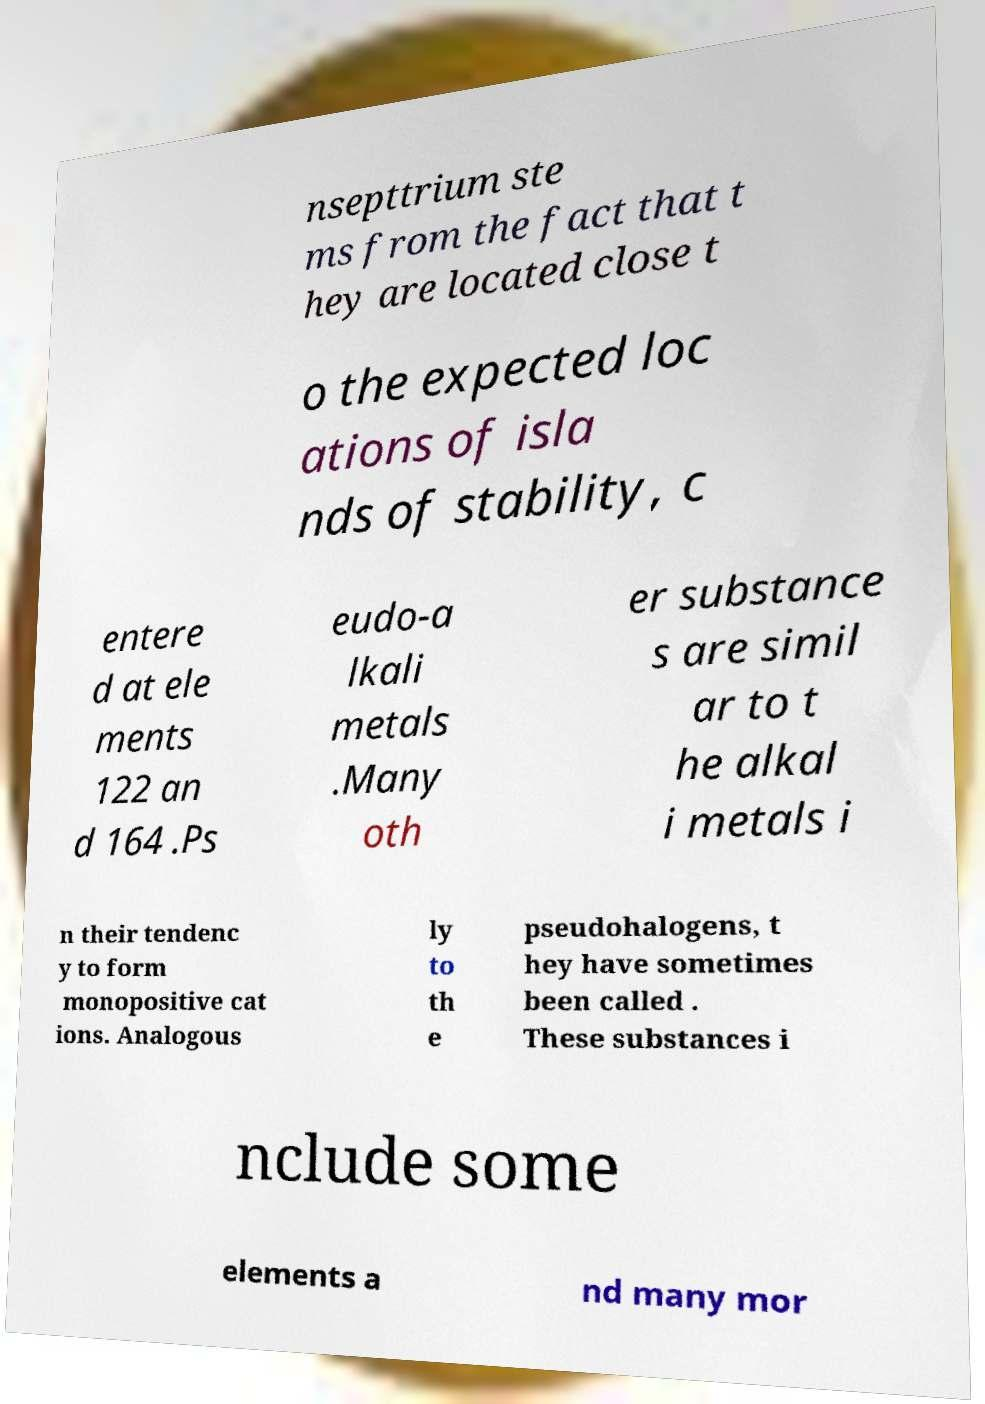Can you accurately transcribe the text from the provided image for me? nsepttrium ste ms from the fact that t hey are located close t o the expected loc ations of isla nds of stability, c entere d at ele ments 122 an d 164 .Ps eudo-a lkali metals .Many oth er substance s are simil ar to t he alkal i metals i n their tendenc y to form monopositive cat ions. Analogous ly to th e pseudohalogens, t hey have sometimes been called . These substances i nclude some elements a nd many mor 